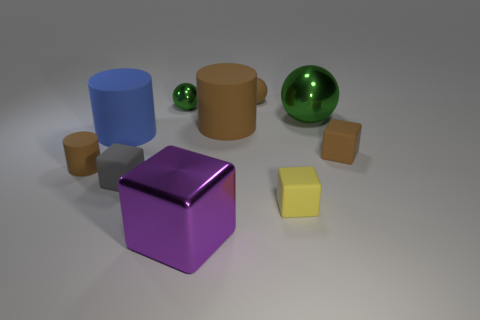What two colors are most dominant in the scene? The two most dominant colors in the scene are green, showcased by the large, shiny sphere, and blue, as seen on the apparel of the large cylinder.  What mood does the composition of the image evoke? The composition of the image evokes a sense of serene order and simplicity, with its clean lines, subdued lighting, and well-defined shapes. 